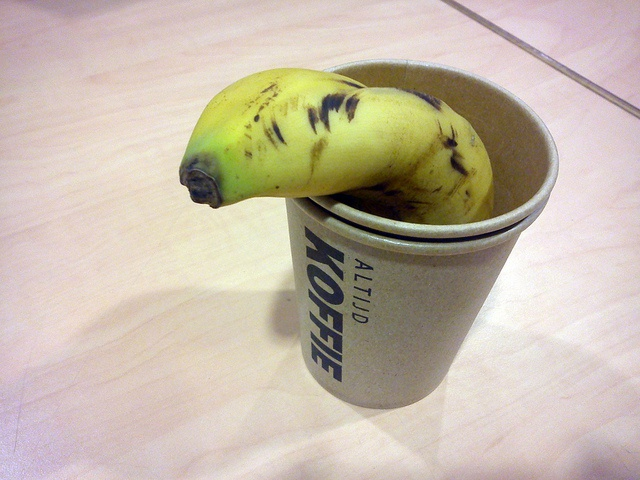Describe the objects in this image and their specific colors. I can see dining table in lightgray, tan, gray, and olive tones, cup in gray, olive, and black tones, and banana in gray, khaki, and olive tones in this image. 